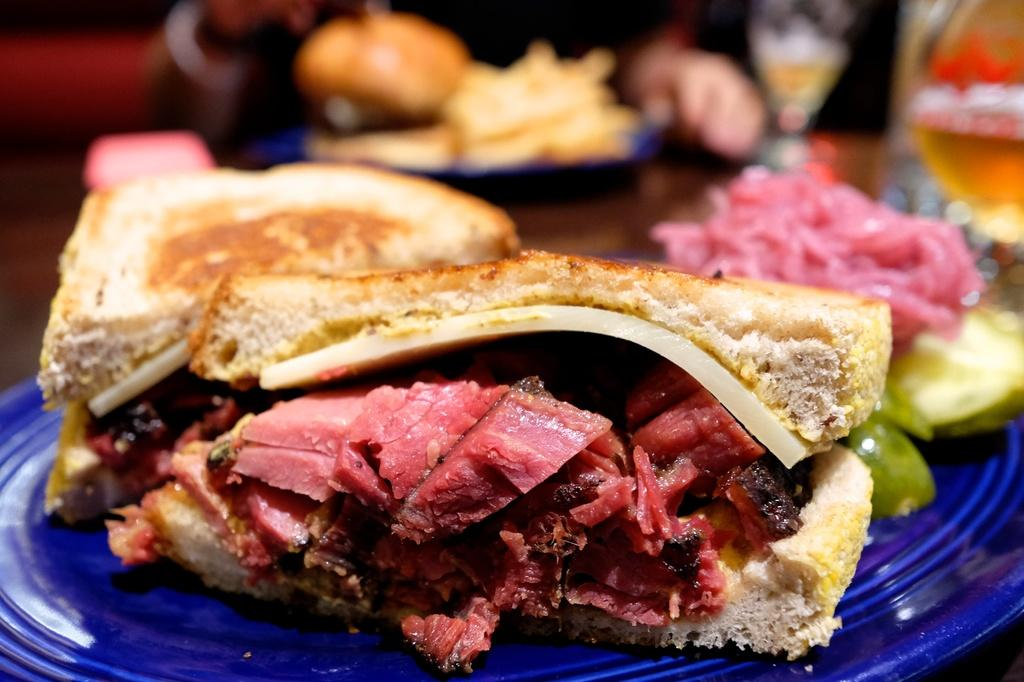What type of food can be seen in the image? There is bread and meat in the image. How is the food presented in the image? The food is served on a blue color plate. Can you describe the background of the image? The background of the image is blurry. What type of pencil can be seen in the image? There is no pencil present in the image. What mineral is visible in the image? There is no mineral, such as quartz, present in the image. 